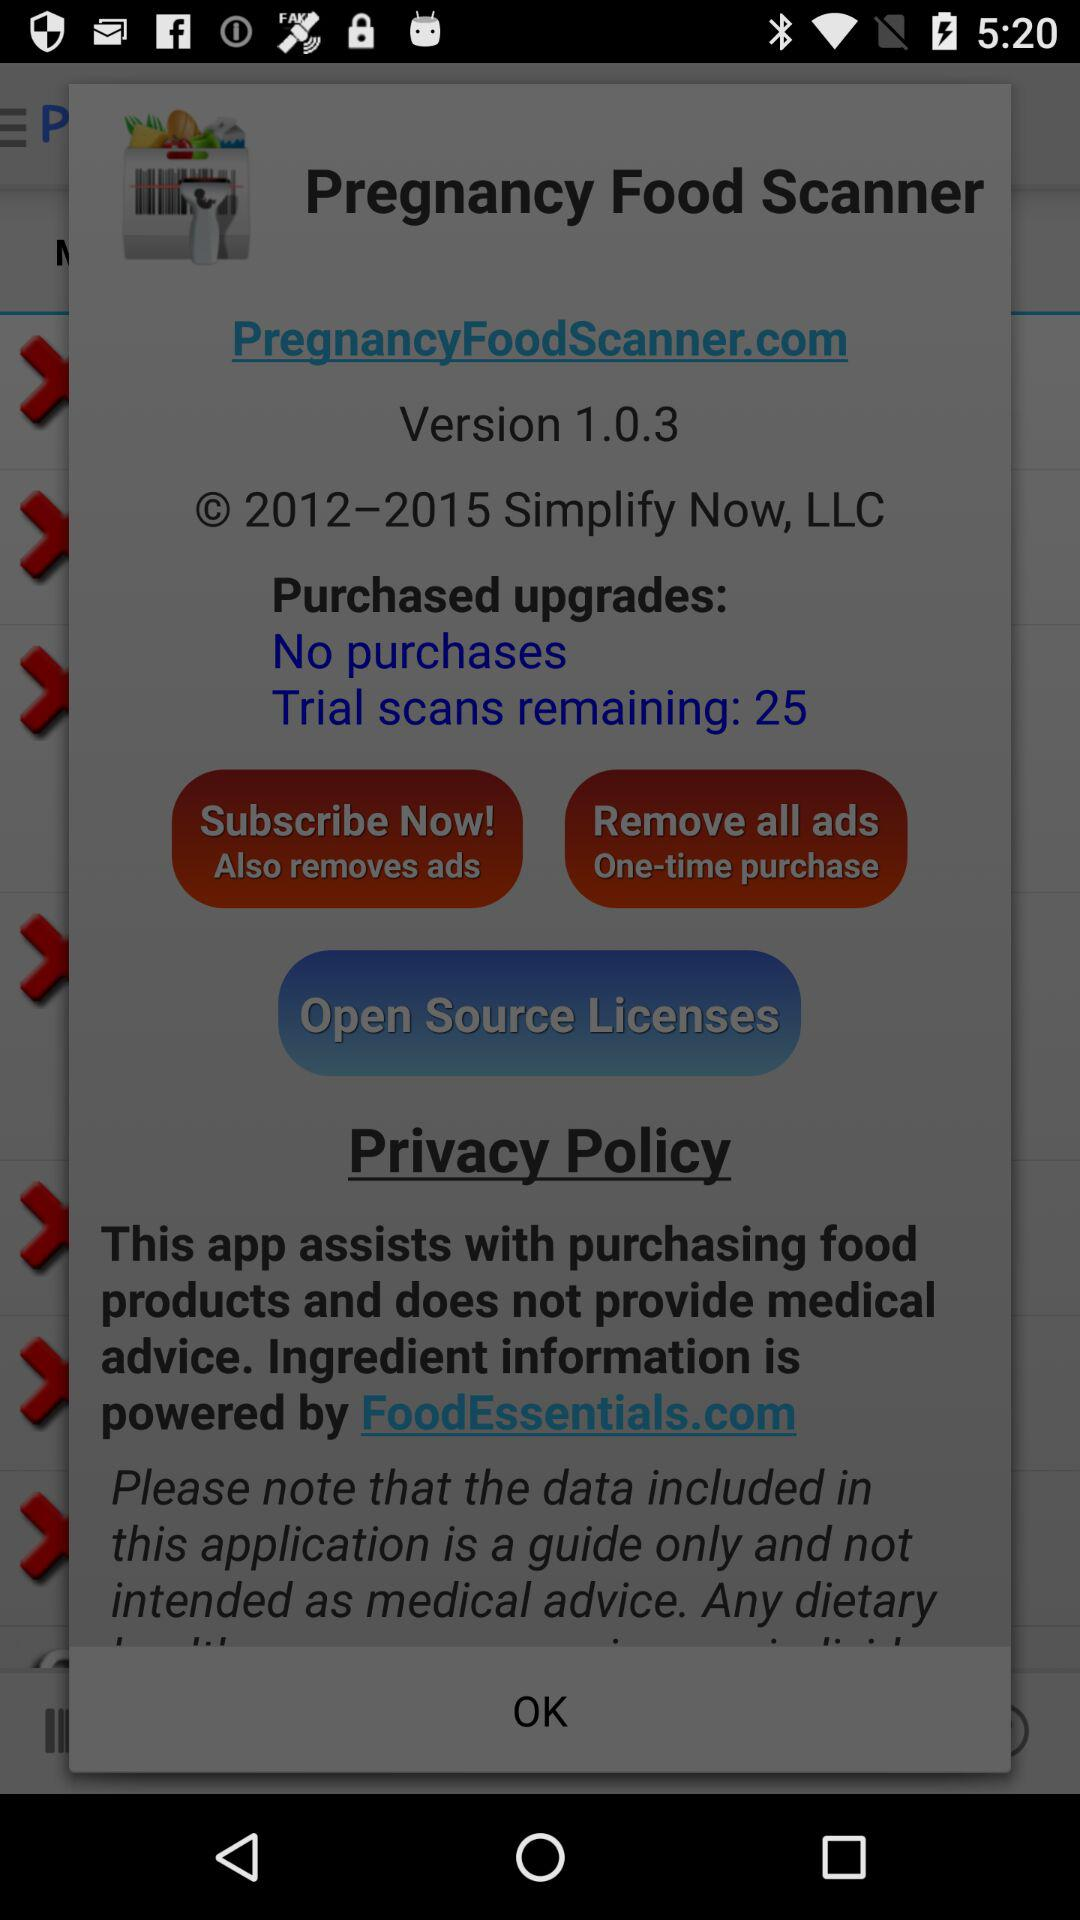What is the version of the application? The version of the application is 1.0.3. 